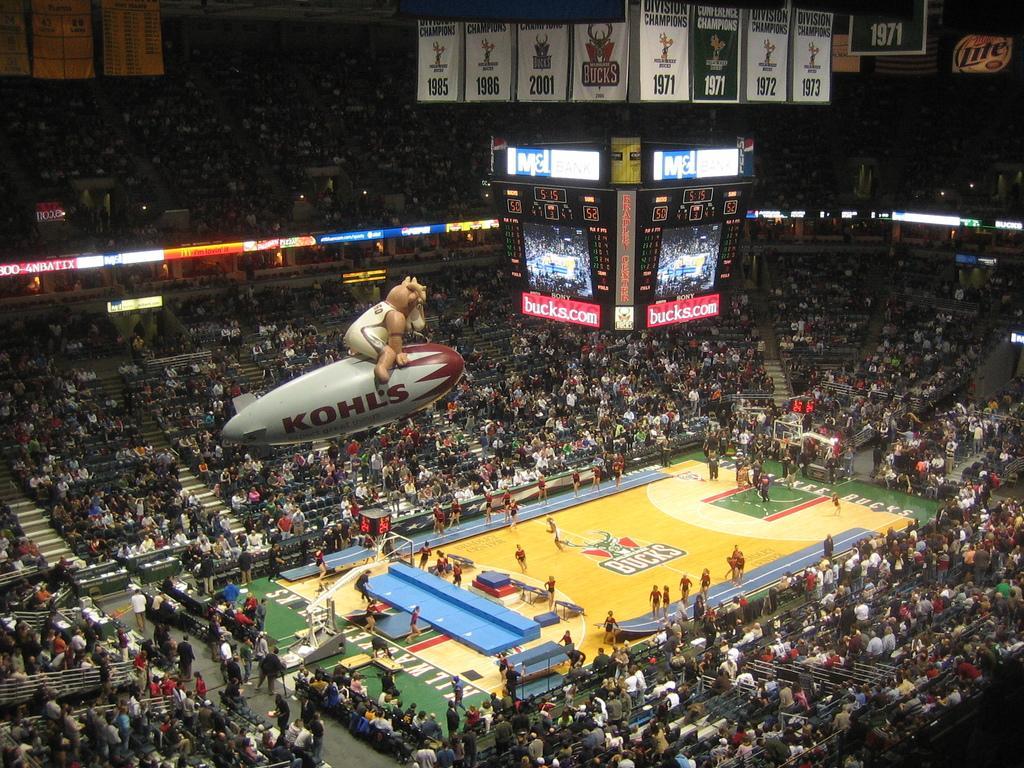Describe this image in one or two sentences. In this image we can see many people in the stadium and in the ground. Here we can see the LED projector screens, air balloon hanged to the ceiling, banners and this part of the images dark. 